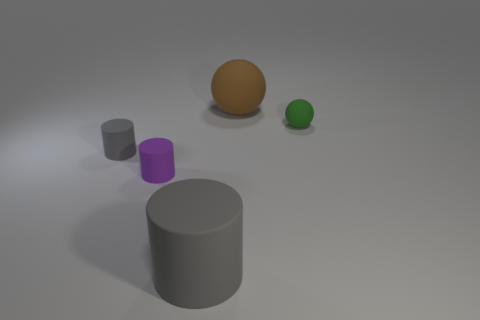There is a matte thing behind the object on the right side of the big matte ball; what number of big gray matte things are right of it?
Your answer should be very brief. 0. What is the shape of the matte thing that is behind the tiny gray rubber object and in front of the brown matte sphere?
Your answer should be compact. Sphere. Are there fewer tiny matte objects that are behind the small green object than tiny red cylinders?
Offer a very short reply. No. What number of small objects are either cylinders or brown cylinders?
Provide a short and direct response. 2. What is the size of the green rubber sphere?
Keep it short and to the point. Small. There is a tiny gray thing; how many brown rubber spheres are left of it?
Make the answer very short. 0. There is a brown matte thing that is the same shape as the tiny green matte thing; what size is it?
Keep it short and to the point. Large. There is a thing that is both right of the purple rubber thing and left of the big brown object; what is its size?
Keep it short and to the point. Large. There is a large matte cylinder; is its color the same as the small cylinder behind the tiny purple rubber thing?
Provide a succinct answer. Yes. How many green things are either matte cylinders or matte objects?
Your answer should be very brief. 1. 